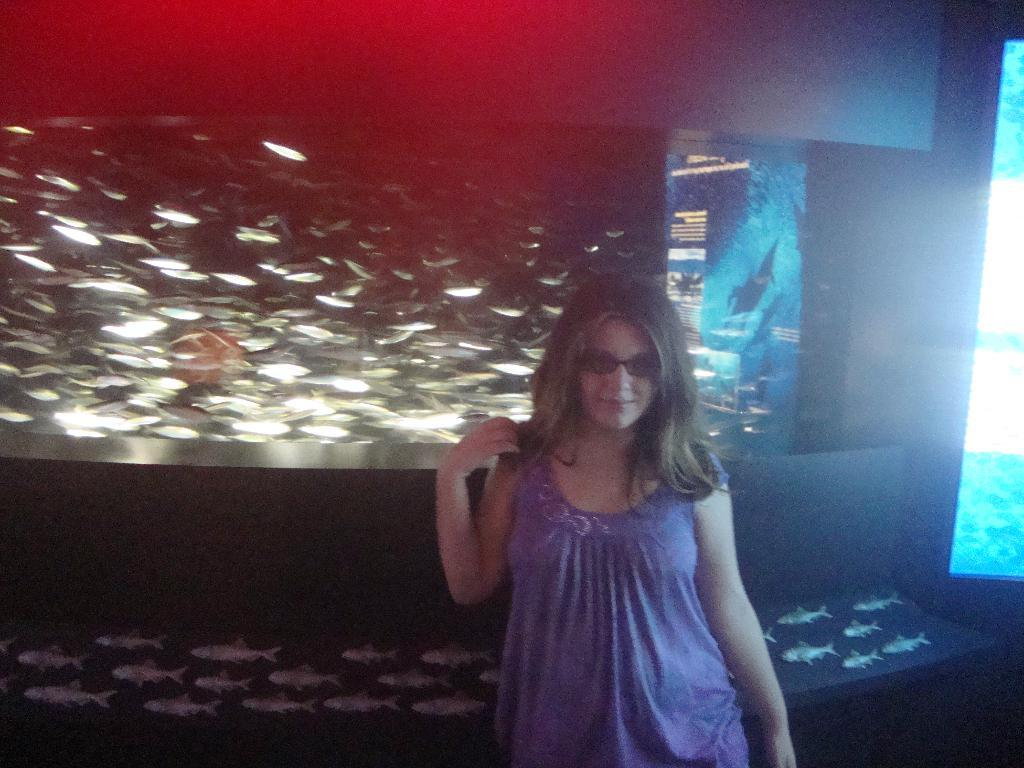Who is present in the image? There is a woman in the image. What can be observed about the woman's appearance? The woman is wearing spectacles. What is the main object visible in the image? There is a screen visible in the image. What is displayed on the screen? The screen displays images of fishes. What type of treatment is being administered to the woman in the image? There is no indication in the image that the woman is receiving any treatment. What role does metal play in the image? There is no mention of metal in the image. 